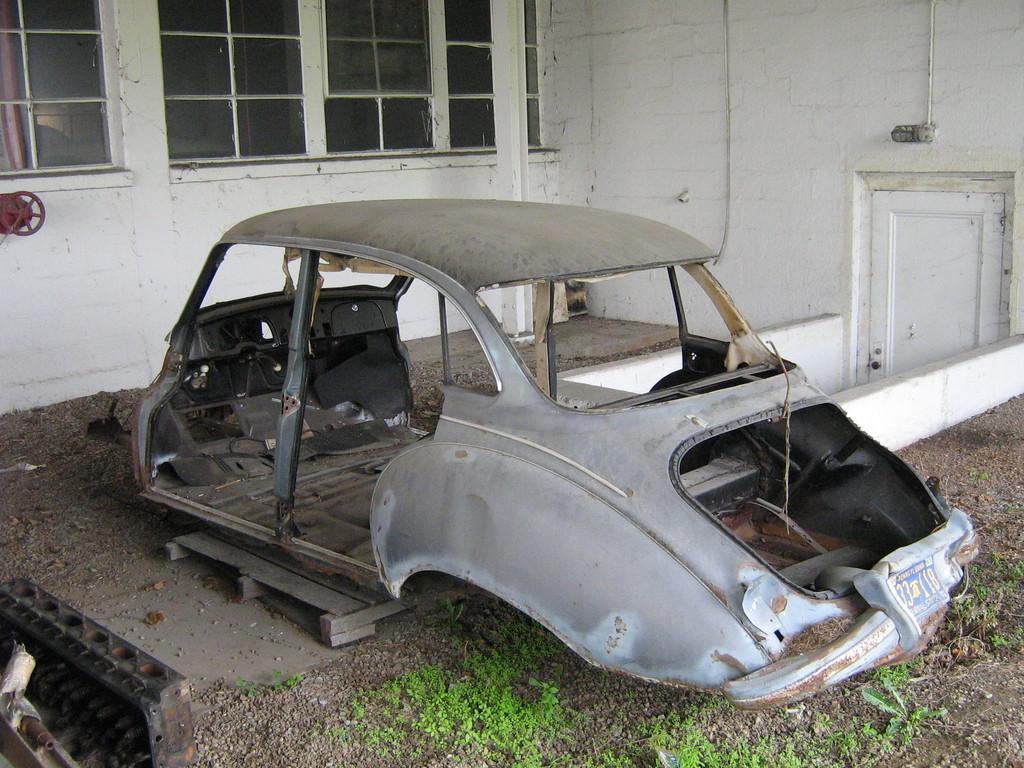In one or two sentences, can you explain what this image depicts? Here we can see vehicle body and plants. Background there are glass windows, wall and door. 